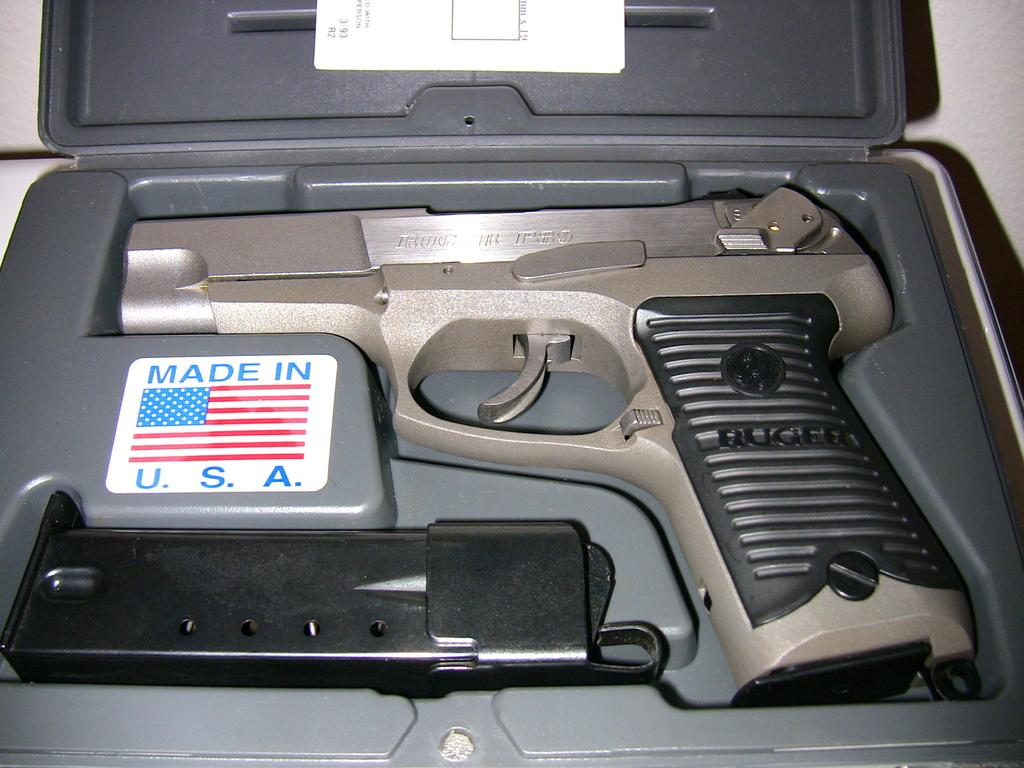What object is present in the image? There is a box in the image. What is inside the box? The box contains a gun and a magazine. What is the color of the magazine? The magazine is black in color. What information is provided by the flag symbol on the box? The flag symbol on the box represents "made in USA." How many feet are visible in the image? There are no feet visible in the image. What type of agreement is being made in the image? There is no agreement being made in the image. 